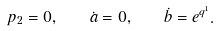<formula> <loc_0><loc_0><loc_500><loc_500>p _ { 2 } = 0 , \quad \dot { a } = 0 , \quad \dot { b } = e ^ { q ^ { 1 } } .</formula> 